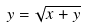<formula> <loc_0><loc_0><loc_500><loc_500>y = \sqrt { x + y }</formula> 